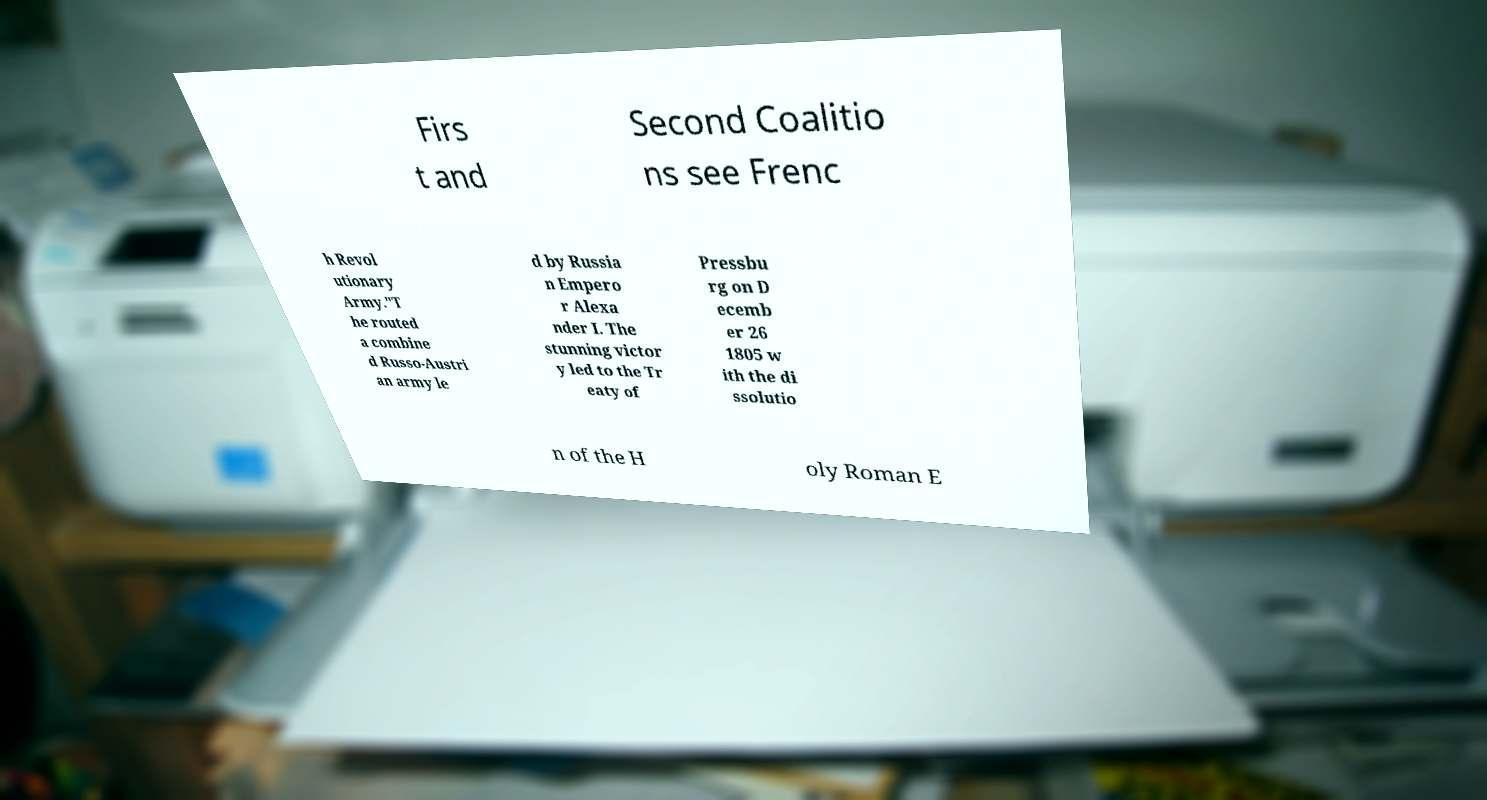For documentation purposes, I need the text within this image transcribed. Could you provide that? Firs t and Second Coalitio ns see Frenc h Revol utionary Army."T he routed a combine d Russo-Austri an army le d by Russia n Empero r Alexa nder I. The stunning victor y led to the Tr eaty of Pressbu rg on D ecemb er 26 1805 w ith the di ssolutio n of the H oly Roman E 